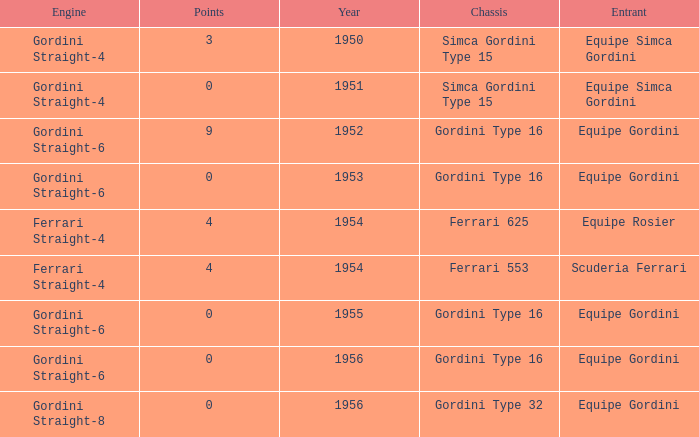How many points after 1956? 0.0. 